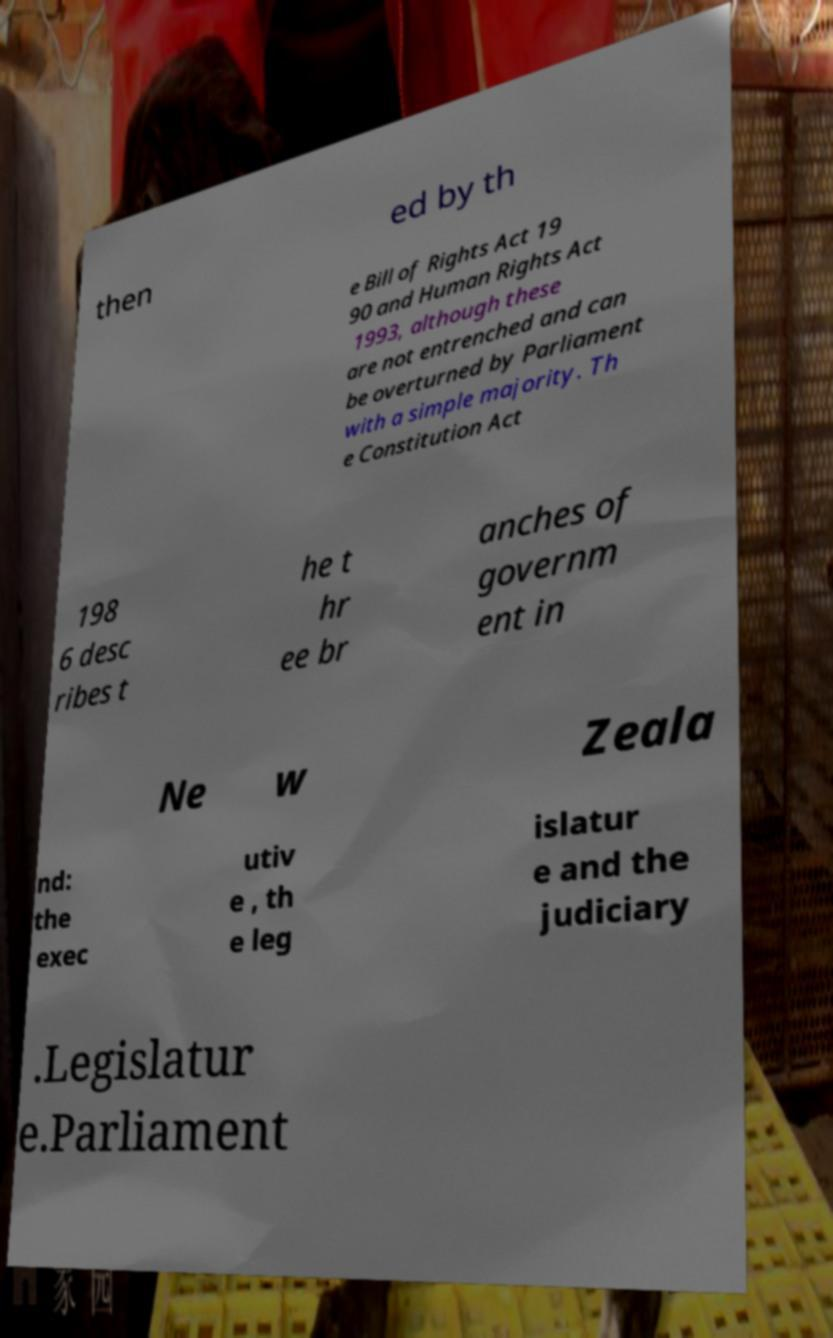Can you read and provide the text displayed in the image?This photo seems to have some interesting text. Can you extract and type it out for me? then ed by th e Bill of Rights Act 19 90 and Human Rights Act 1993, although these are not entrenched and can be overturned by Parliament with a simple majority. Th e Constitution Act 198 6 desc ribes t he t hr ee br anches of governm ent in Ne w Zeala nd: the exec utiv e , th e leg islatur e and the judiciary .Legislatur e.Parliament 